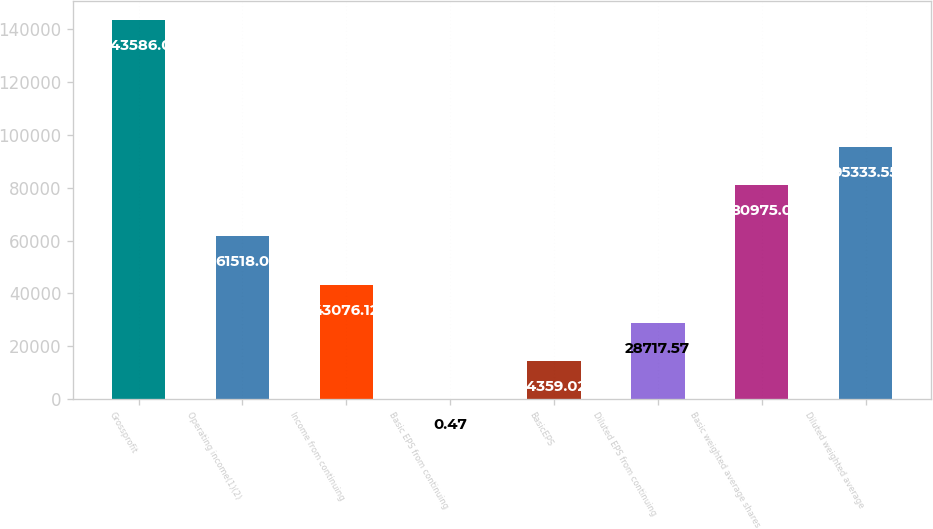Convert chart. <chart><loc_0><loc_0><loc_500><loc_500><bar_chart><fcel>Grossprofit<fcel>Operating income(1)(2)<fcel>Income from continuing<fcel>Basic EPS from continuing<fcel>BasicEPS<fcel>Diluted EPS from continuing<fcel>Basic weighted average shares<fcel>Diluted weighted average<nl><fcel>143586<fcel>61518<fcel>43076.1<fcel>0.47<fcel>14359<fcel>28717.6<fcel>80975<fcel>95333.6<nl></chart> 